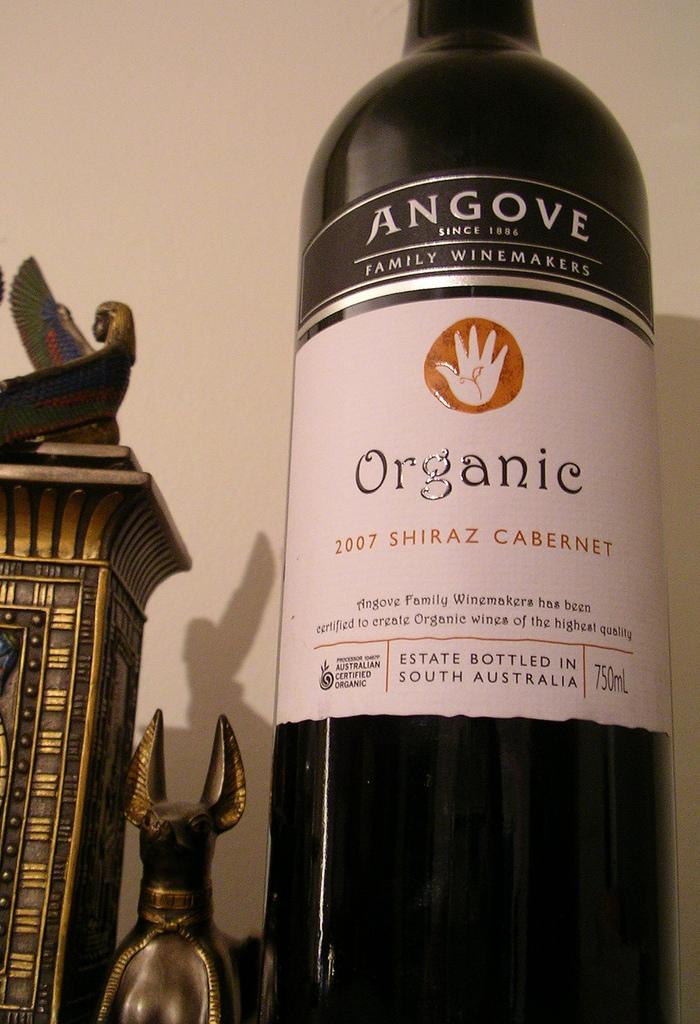Provide a one-sentence caption for the provided image. Bottle of organic wine that is shiraz cabinet. 